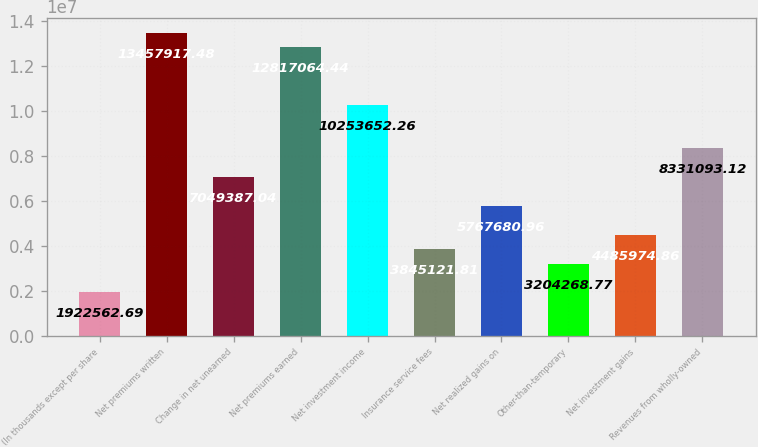<chart> <loc_0><loc_0><loc_500><loc_500><bar_chart><fcel>(In thousands except per share<fcel>Net premiums written<fcel>Change in net unearned<fcel>Net premiums earned<fcel>Net investment income<fcel>Insurance service fees<fcel>Net realized gains on<fcel>Other-than-temporary<fcel>Net investment gains<fcel>Revenues from wholly-owned<nl><fcel>1.92256e+06<fcel>1.34579e+07<fcel>7.04939e+06<fcel>1.28171e+07<fcel>1.02537e+07<fcel>3.84512e+06<fcel>5.76768e+06<fcel>3.20427e+06<fcel>4.48597e+06<fcel>8.33109e+06<nl></chart> 